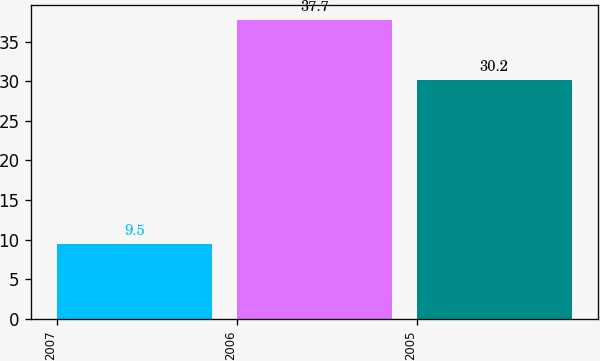<chart> <loc_0><loc_0><loc_500><loc_500><bar_chart><fcel>2007<fcel>2006<fcel>2005<nl><fcel>9.5<fcel>37.7<fcel>30.2<nl></chart> 